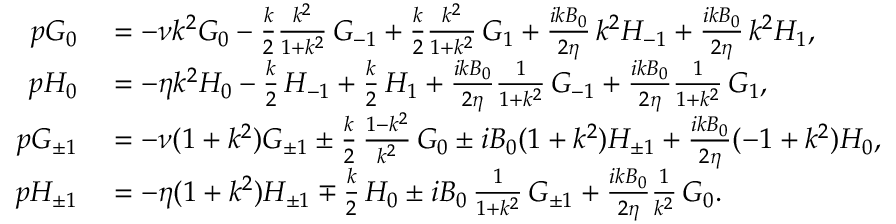<formula> <loc_0><loc_0><loc_500><loc_500>\begin{array} { r l } { p G _ { 0 } } & = - \nu k ^ { 2 } G _ { 0 } - \frac { k } { 2 } \frac { k ^ { 2 } } { 1 + k ^ { 2 } } \, G _ { - 1 } + \frac { k } { 2 } \frac { k ^ { 2 } } { 1 + k ^ { 2 } } \, G _ { 1 } + \frac { i k B _ { 0 } } { 2 \eta } \, k ^ { 2 } H _ { - 1 } + \frac { i k B _ { 0 } } { 2 \eta } \, k ^ { 2 } H _ { 1 } , } \\ { p H _ { 0 } } & = - \eta k ^ { 2 } H _ { 0 } - \frac { k } { 2 } \, H _ { - 1 } + \frac { k } { 2 } \, H _ { 1 } + \frac { i k B _ { 0 } } { 2 \eta } \frac { 1 } { 1 + k ^ { 2 } } \, G _ { - 1 } + \frac { i k B _ { 0 } } { 2 \eta } \frac { 1 } { 1 + k ^ { 2 } } \, G _ { 1 } , } \\ { p G _ { \pm 1 } } & = - \nu ( 1 + k ^ { 2 } ) G _ { \pm 1 } \pm \frac { k } { 2 } \, \frac { 1 - k ^ { 2 } } { k ^ { 2 } } \, G _ { 0 } \pm i B _ { 0 } ( 1 + k ^ { 2 } ) H _ { \pm 1 } + \frac { i k B _ { 0 } } { 2 \eta } ( - 1 + k ^ { 2 } ) H _ { 0 } , } \\ { p H _ { \pm 1 } } & = - \eta ( 1 + k ^ { 2 } ) H _ { \pm 1 } \mp \frac { k } { 2 } \, H _ { 0 } \pm i B _ { 0 } \, \frac { 1 } { 1 + k ^ { 2 } } \, G _ { \pm 1 } + \frac { i k B _ { 0 } } { 2 \eta } \frac { 1 } { k ^ { 2 } } \, G _ { 0 } . } \end{array}</formula> 